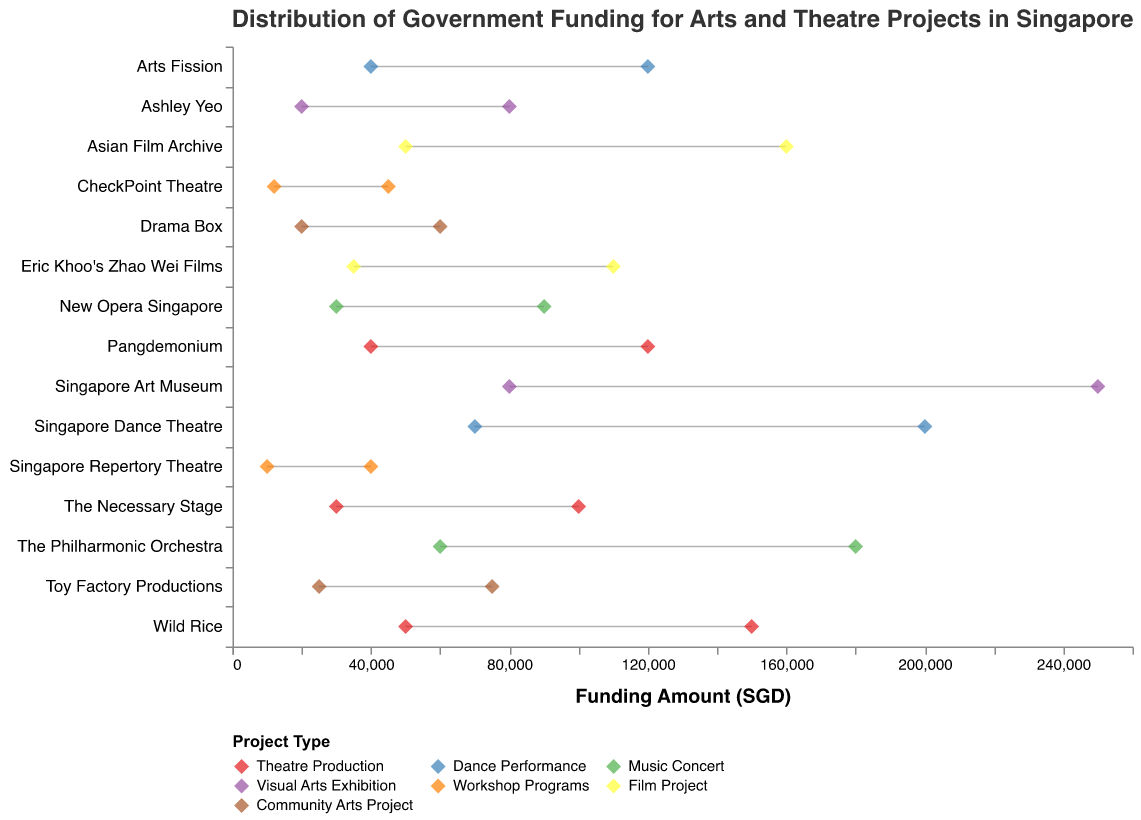What is the minimum funding provided to the Singapore Art Museum? Look for the Singapore Art Museum in the Visual Arts Exhibition category and identify the minimum funding amount from the plotted dots.
Answer: 80000 What is the title of the figure? The title is located at the top of the plot, conveying the main subject of the visualization.
Answer: Distribution of Government Funding for Arts and Theatre Projects in Singapore Which organization received the highest maximum funding, and what is that amount? Identify the point with the highest maximum funding on the x-axis, then check which organization it corresponds to; in this case, it's the Singapore Art Museum.
Answer: Singapore Art Museum, 250000 What is the range of government funding for the organization Wild Rice? Find Wild Rice under Theatre Production and note the minimum and maximum funding amounts. Calculate the difference between these two values: 150000 - 50000.
Answer: 100000 How many types of project categories are represented in the figure? Count the unique project types listed in the legend at the bottom.
Answer: 7 What is the average minimum funding amount for Theatre Production projects? Identify the minimum funding amounts for all Theatre Production projects, sum them (50000 + 40000 + 30000), then divide by the number of projects (3). Calculation: (50000 + 40000 + 30000) / 3.
Answer: 40000 Which category has the largest variability in funding amounts? Compare the range (maximum - minimum) for each category. Visual Arts Exhibition has the largest range (250000 - 20000 = 230000).
Answer: Visual Arts Exhibition Is the minimum funding for Dance Performances greater than the maximum funding for Workshop Programs? Find the minimum funding for Dance Performance (40000) and the maximum funding for Workshop Programs (45000), and compare them.
Answer: No Which has a higher range of funding: The Philharmonic Orchestra or New Opera Singapore? Subtract the minimum funding from the maximum funding for both organizations and compare: The Philharmonic Orchestra (180000 - 60000 = 120000) vs. New Opera Singapore (90000 - 30000 = 60000).
Answer: The Philharmonic Orchestra For the Film Project category, what is the difference in maximum funding between the Asian Film Archive and Eric Khoo's Zhao Wei Films? Identify the maximum funding for the Asian Film Archive (160000) and Eric Khoo's Zhao Wei Films (110000), then subtract the latter from the former: 160000 - 110000.
Answer: 50000 